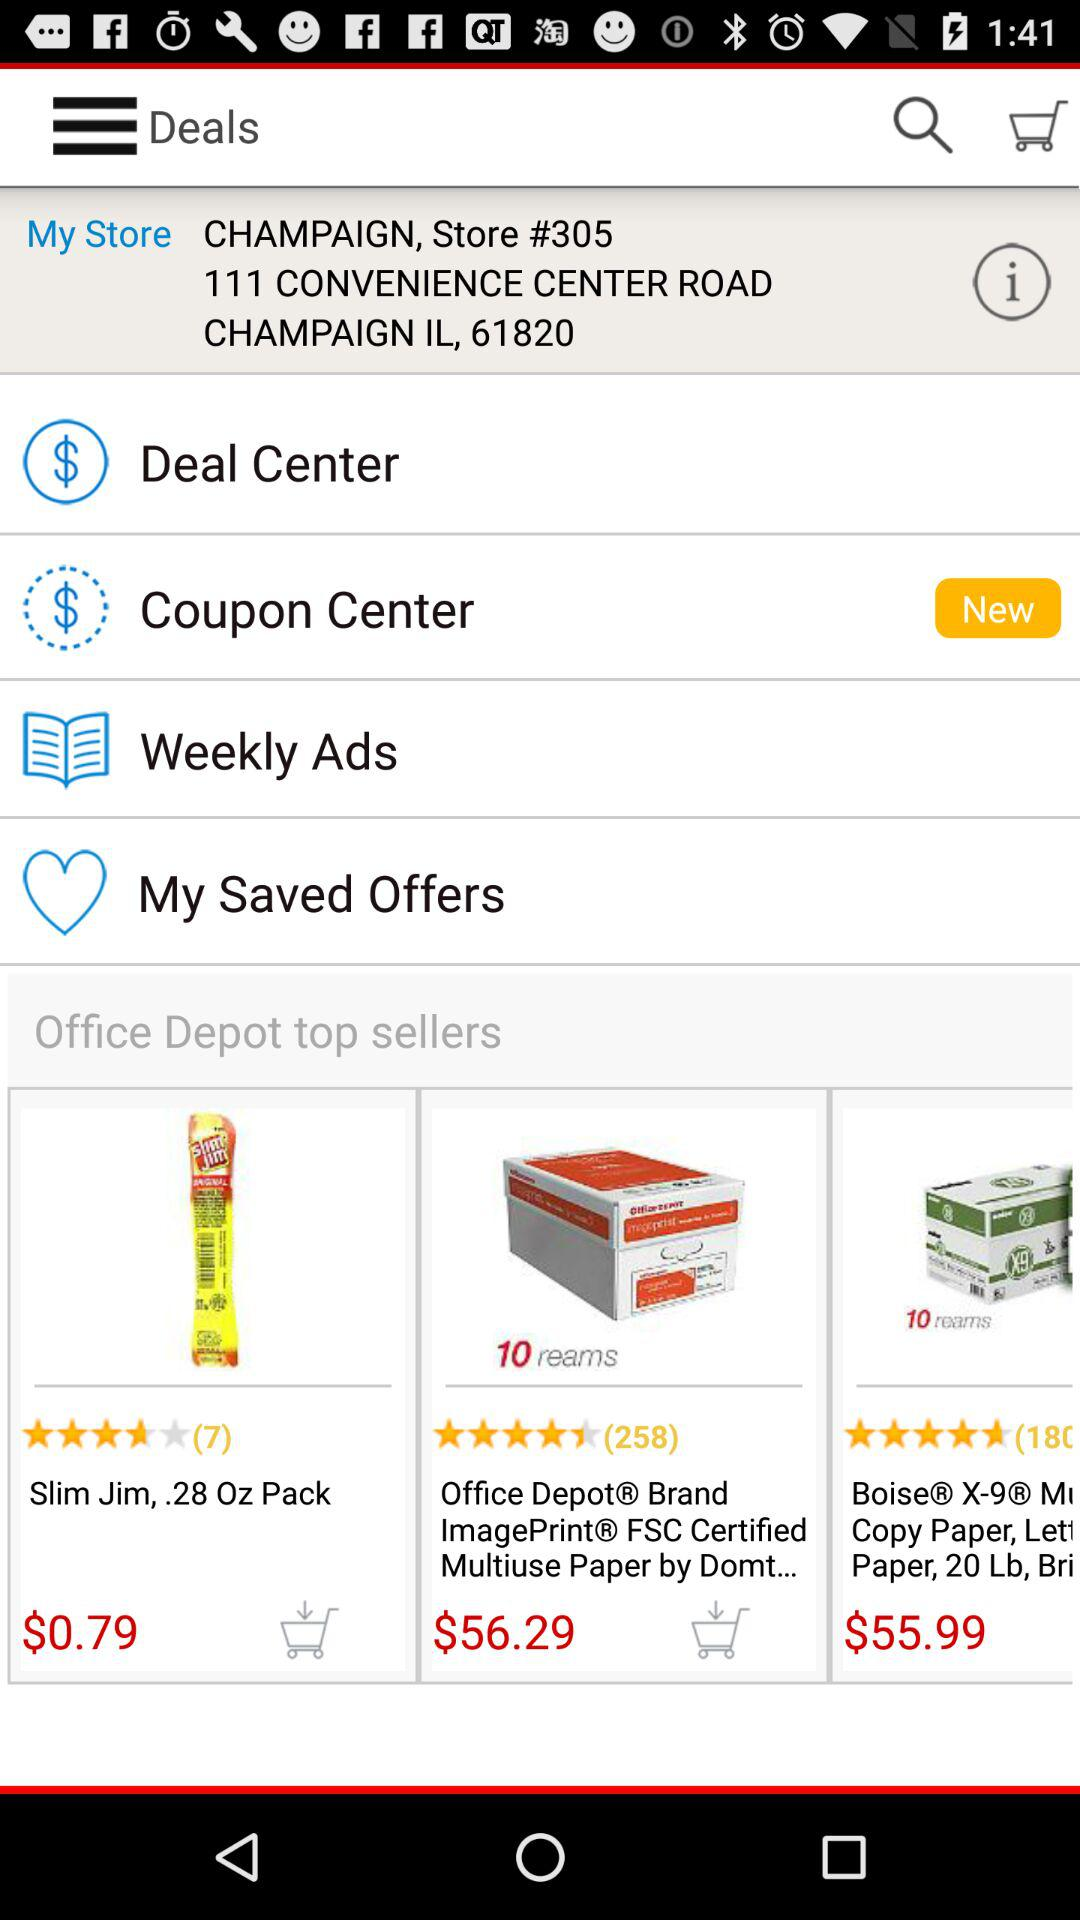Is there any new coupon center?
When the provided information is insufficient, respond with <no answer>. <no answer> 